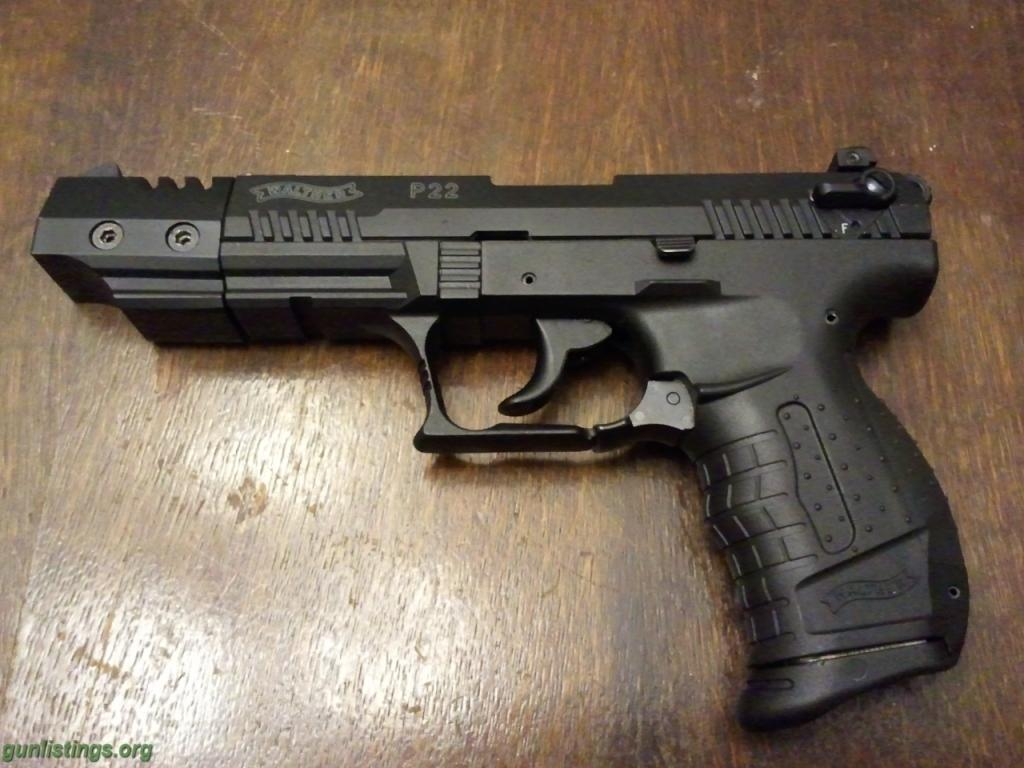What object is the main focus of the image? There is a gun in the image. Where is the gun placed? The gun is placed on a wooden object, possibly a table. Is there any text visible in the image? Yes, there is text visible in the bottom left corner of the image. What type of fruit is being tested in the image? There is no fruit or testing activity present in the image; it features a gun placed on a wooden object. How many straws are visible in the image? There are no straws present in the image. 